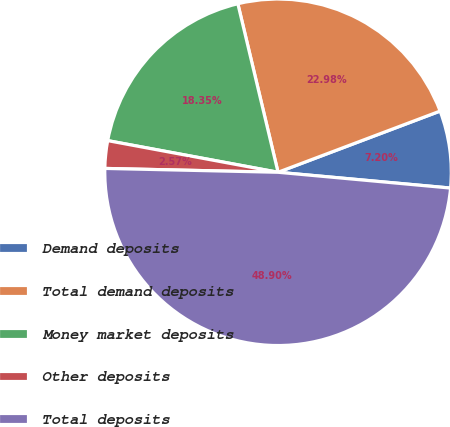<chart> <loc_0><loc_0><loc_500><loc_500><pie_chart><fcel>Demand deposits<fcel>Total demand deposits<fcel>Money market deposits<fcel>Other deposits<fcel>Total deposits<nl><fcel>7.2%<fcel>22.98%<fcel>18.35%<fcel>2.57%<fcel>48.9%<nl></chart> 